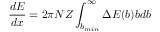Convert formula to latex. <formula><loc_0><loc_0><loc_500><loc_500>{ \frac { d E } { d x } } = 2 \pi N Z \int _ { b _ { \min } } ^ { \infty } \Delta E ( b ) b d b</formula> 